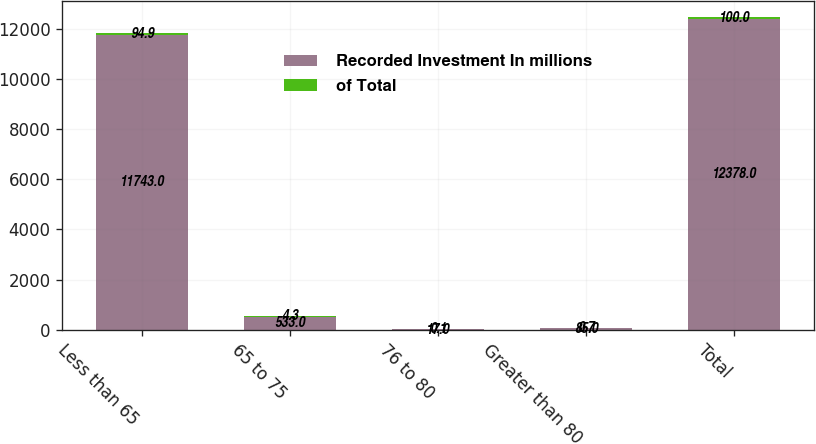<chart> <loc_0><loc_0><loc_500><loc_500><stacked_bar_chart><ecel><fcel>Less than 65<fcel>65 to 75<fcel>76 to 80<fcel>Greater than 80<fcel>Total<nl><fcel>Recorded Investment In millions<fcel>11743<fcel>533<fcel>17<fcel>85<fcel>12378<nl><fcel>of Total<fcel>94.9<fcel>4.3<fcel>0.1<fcel>0.7<fcel>100<nl></chart> 